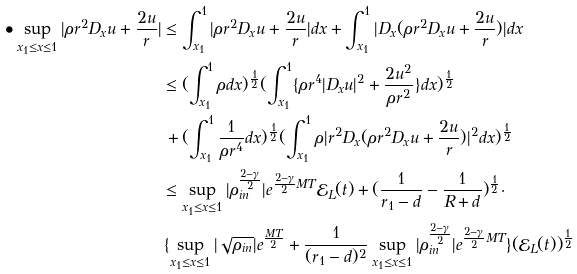<formula> <loc_0><loc_0><loc_500><loc_500>\bullet \sup _ { x _ { 1 } \leq x \leq 1 } | \rho r ^ { 2 } D _ { x } u + \frac { 2 u } { r } | & \leq \int _ { x _ { 1 } } ^ { 1 } | \rho r ^ { 2 } D _ { x } u + \frac { 2 u } { r } | d x + \int _ { x _ { 1 } } ^ { 1 } | D _ { x } ( \rho r ^ { 2 } D _ { x } u + \frac { 2 u } { r } ) | d x \\ & \leq ( \int _ { x _ { 1 } } ^ { 1 } \rho d x ) ^ { \frac { 1 } { 2 } } ( \int _ { x _ { 1 } } ^ { 1 } \{ \rho r ^ { 4 } | D _ { x } u | ^ { 2 } + \frac { 2 u ^ { 2 } } { \rho r ^ { 2 } } \} d x ) ^ { \frac { 1 } { 2 } } \\ & \, + ( \int _ { x _ { 1 } } ^ { 1 } \frac { 1 } { \rho r ^ { 4 } } d x ) ^ { \frac { 1 } { 2 } } ( \int _ { x _ { 1 } } ^ { 1 } \rho | r ^ { 2 } D _ { x } ( \rho r ^ { 2 } D _ { x } u + \frac { 2 u } { r } ) | ^ { 2 } d x ) ^ { \frac { 1 } { 2 } } \\ & \leq \sup _ { x _ { 1 } \leq x \leq 1 } | \rho _ { i n } ^ { \frac { 2 - \gamma } { 2 } } | e ^ { \frac { 2 - \gamma } { 2 } M T } \mathcal { E } _ { L } ( t ) + ( \frac { 1 } { r _ { 1 } - d } - \frac { 1 } { R + d } ) ^ { \frac { 1 } { 2 } } \cdot \\ & \, \{ \sup _ { x _ { 1 } \leq x \leq 1 } | \sqrt { \rho _ { i n } } | e ^ { \frac { M T } { 2 } } + \frac { 1 } { ( r _ { 1 } - d ) ^ { 2 } } \sup _ { x _ { 1 } \leq x \leq 1 } | \rho _ { i n } ^ { \frac { 2 - \gamma } { 2 } } | e ^ { \frac { 2 - \gamma } { 2 } M T } \} ( \mathcal { E } _ { L } ( t ) ) ^ { \frac { 1 } { 2 } }</formula> 